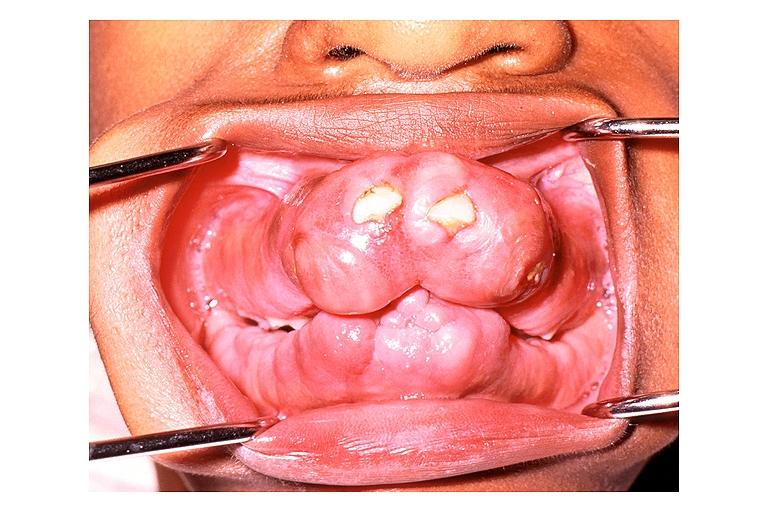what is present?
Answer the question using a single word or phrase. Oral 